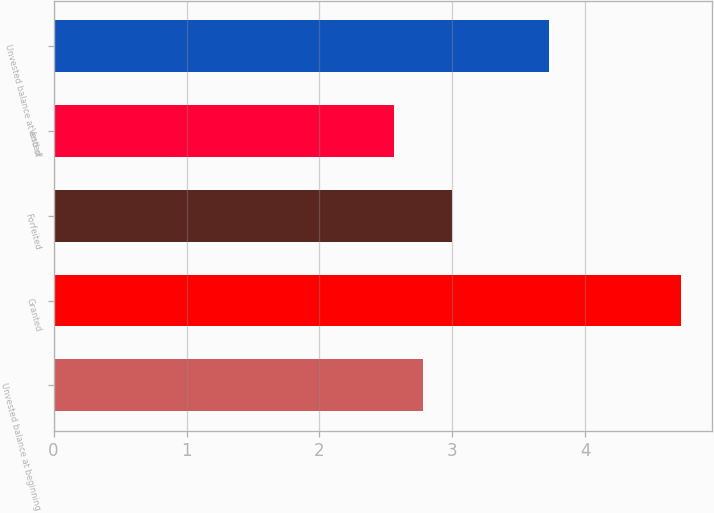Convert chart. <chart><loc_0><loc_0><loc_500><loc_500><bar_chart><fcel>Unvested balance at beginning<fcel>Granted<fcel>Forfeited<fcel>Vested<fcel>Unvested balance at end of<nl><fcel>2.78<fcel>4.72<fcel>3<fcel>2.56<fcel>3.73<nl></chart> 